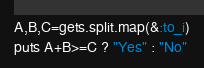<code> <loc_0><loc_0><loc_500><loc_500><_Ruby_>A,B,C=gets.split.map(&:to_i)
puts A+B>=C ? "Yes" : "No"
</code> 